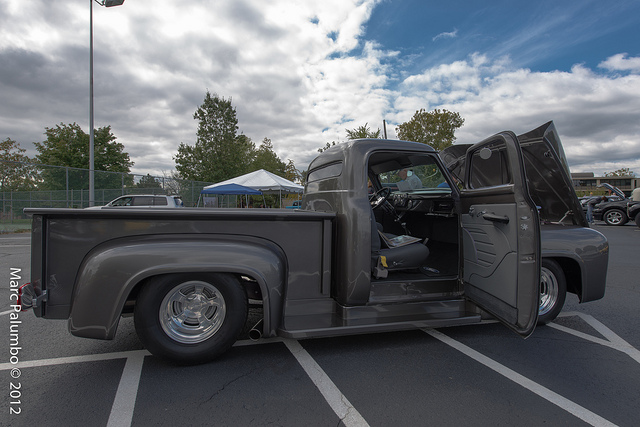Please transcribe the text in this image. 2012 Palumbo Marc 